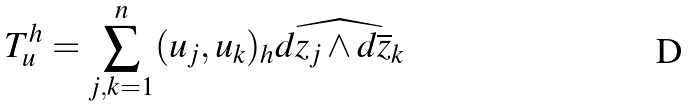<formula> <loc_0><loc_0><loc_500><loc_500>T ^ { h } _ { u } = \sum ^ { n } _ { j , k = 1 } ( u _ { j } , u _ { k } ) _ { h } \widehat { d z _ { j } \wedge d \overline { z } _ { k } }</formula> 